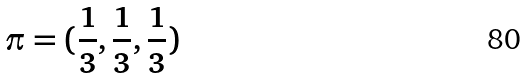<formula> <loc_0><loc_0><loc_500><loc_500>\pi = ( \frac { 1 } { 3 } , \frac { 1 } { 3 } , \frac { 1 } { 3 } )</formula> 